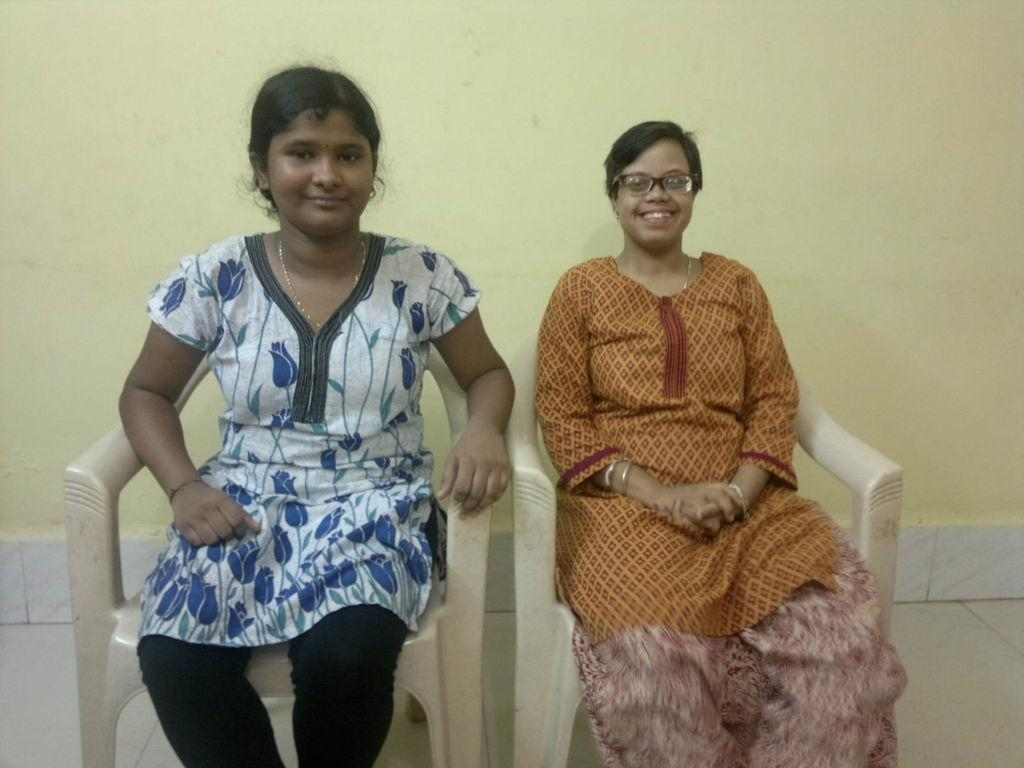How many people are in the image? There are two people in the image. What are the people doing in the image? The people are sitting on chairs. What can be seen in the background of the image? There is a wall in the background of the image. What type of digestion issues are the people experiencing in the image? There is no indication of digestion issues in the image; the people are simply sitting on chairs. 